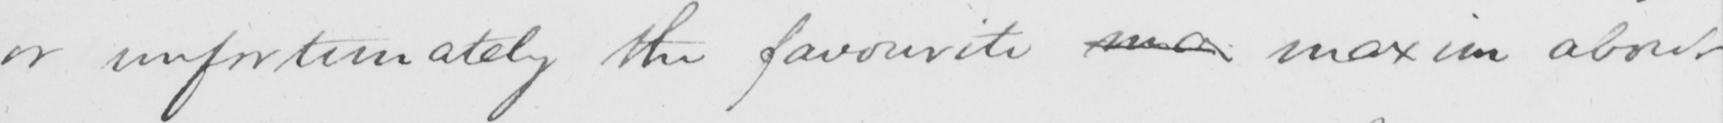Please provide the text content of this handwritten line. or unfortunately the favourite ma maxim about 